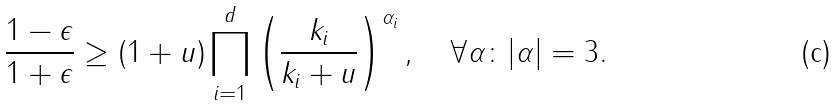<formula> <loc_0><loc_0><loc_500><loc_500>\frac { 1 - \epsilon } { 1 + \epsilon } \geq ( 1 + u ) \prod _ { i = 1 } ^ { d } \left ( \frac { k _ { i } } { k _ { i } + u } \right ) ^ { \alpha _ { i } } , \quad \forall \alpha \colon | \alpha | = 3 .</formula> 